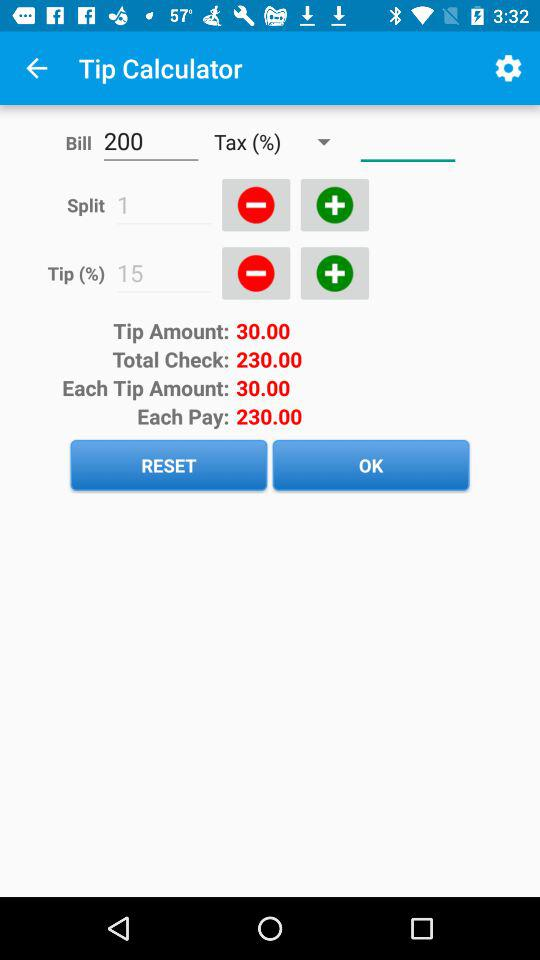How much is each pay? The each pay is 230.00. 